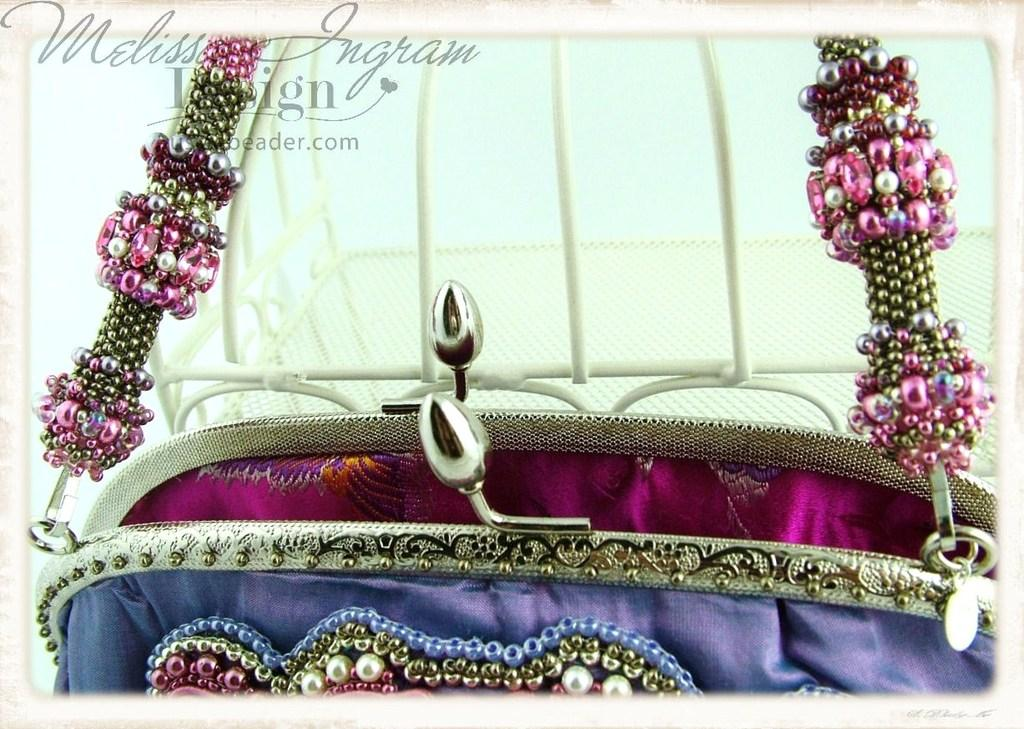What type of accessory is visible in the image? There is a handbag present in the image. Can you describe the appearance of the handbag? The handbag is colorful. What specific colors can be seen on the handbag? The handbag is blue and pink in color. How many oranges are stored inside the handbag in the image? There are no oranges present in the image, as it features a handbag and not a fruit storage container. 